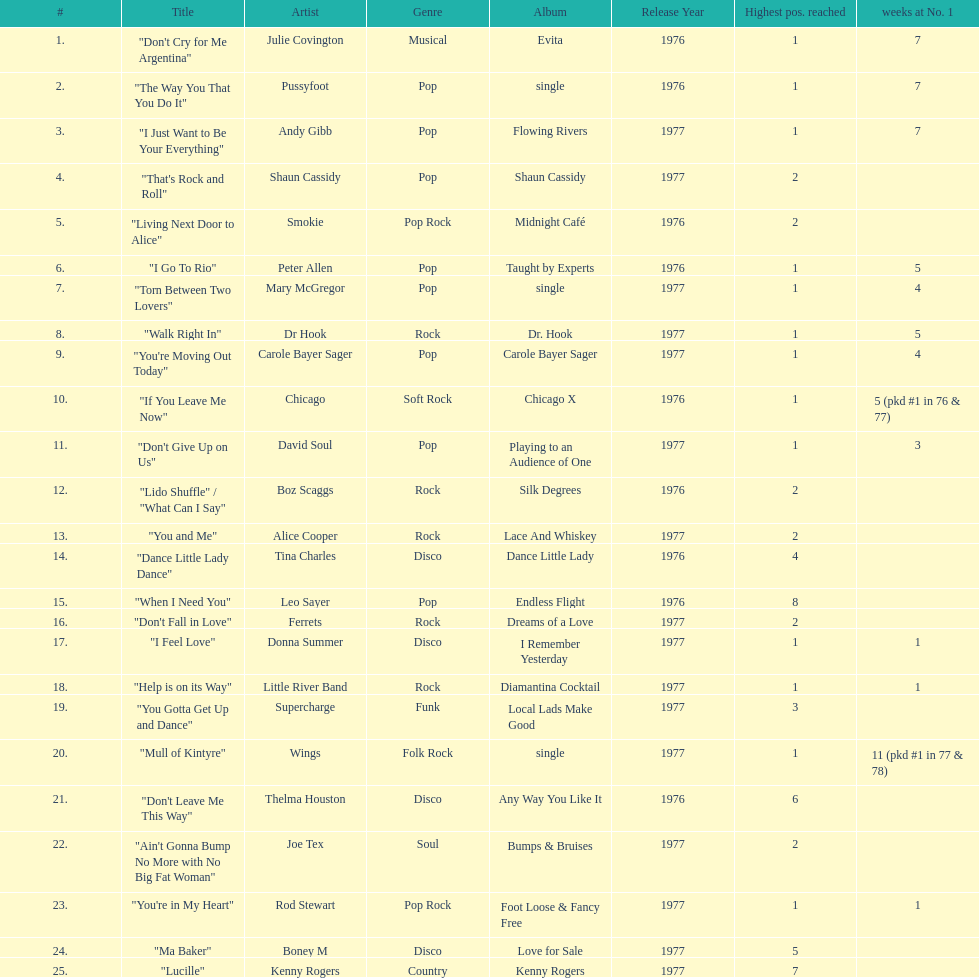What was the number of weeks that julie covington's single " don't cry for me argentinia," was at number 1 in 1977? 7. Could you parse the entire table as a dict? {'header': ['#', 'Title', 'Artist', 'Genre', 'Album', 'Release Year', 'Highest pos. reached', 'weeks at No. 1'], 'rows': [['1.', '"Don\'t Cry for Me Argentina"', 'Julie Covington', 'Musical', 'Evita', '1976', '1', '7'], ['2.', '"The Way You That You Do It"', 'Pussyfoot', 'Pop', 'single', '1976', '1', '7'], ['3.', '"I Just Want to Be Your Everything"', 'Andy Gibb', 'Pop', 'Flowing Rivers', '1977', '1', '7'], ['4.', '"That\'s Rock and Roll"', 'Shaun Cassidy', 'Pop', 'Shaun Cassidy', '1977', '2', ''], ['5.', '"Living Next Door to Alice"', 'Smokie', 'Pop Rock', 'Midnight Café', '1976', '2', ''], ['6.', '"I Go To Rio"', 'Peter Allen', 'Pop', 'Taught by Experts', '1976', '1', '5'], ['7.', '"Torn Between Two Lovers"', 'Mary McGregor', 'Pop', 'single', '1977', '1', '4'], ['8.', '"Walk Right In"', 'Dr Hook', 'Rock', 'Dr. Hook', '1977', '1', '5'], ['9.', '"You\'re Moving Out Today"', 'Carole Bayer Sager', 'Pop', 'Carole Bayer Sager', '1977', '1', '4'], ['10.', '"If You Leave Me Now"', 'Chicago', 'Soft Rock', 'Chicago X', '1976', '1', '5 (pkd #1 in 76 & 77)'], ['11.', '"Don\'t Give Up on Us"', 'David Soul', 'Pop', 'Playing to an Audience of One', '1977', '1', '3'], ['12.', '"Lido Shuffle" / "What Can I Say"', 'Boz Scaggs', 'Rock', 'Silk Degrees', '1976', '2', ''], ['13.', '"You and Me"', 'Alice Cooper', 'Rock', 'Lace And Whiskey', '1977', '2', ''], ['14.', '"Dance Little Lady Dance"', 'Tina Charles', 'Disco', 'Dance Little Lady', '1976', '4', ''], ['15.', '"When I Need You"', 'Leo Sayer', 'Pop', 'Endless Flight', '1976', '8', ''], ['16.', '"Don\'t Fall in Love"', 'Ferrets', 'Rock', 'Dreams of a Love', '1977', '2', ''], ['17.', '"I Feel Love"', 'Donna Summer', 'Disco', 'I Remember Yesterday', '1977', '1', '1'], ['18.', '"Help is on its Way"', 'Little River Band', 'Rock', 'Diamantina Cocktail', '1977', '1', '1'], ['19.', '"You Gotta Get Up and Dance"', 'Supercharge', 'Funk', 'Local Lads Make Good', '1977', '3', ''], ['20.', '"Mull of Kintyre"', 'Wings', 'Folk Rock', 'single', '1977', '1', '11 (pkd #1 in 77 & 78)'], ['21.', '"Don\'t Leave Me This Way"', 'Thelma Houston', 'Disco', 'Any Way You Like It', '1976', '6', ''], ['22.', '"Ain\'t Gonna Bump No More with No Big Fat Woman"', 'Joe Tex', 'Soul', 'Bumps & Bruises', '1977', '2', ''], ['23.', '"You\'re in My Heart"', 'Rod Stewart', 'Pop Rock', 'Foot Loose & Fancy Free', '1977', '1', '1'], ['24.', '"Ma Baker"', 'Boney M', 'Disco', 'Love for Sale', '1977', '5', ''], ['25.', '"Lucille"', 'Kenny Rogers', 'Country', 'Kenny Rogers', '1977', '7', '']]} 